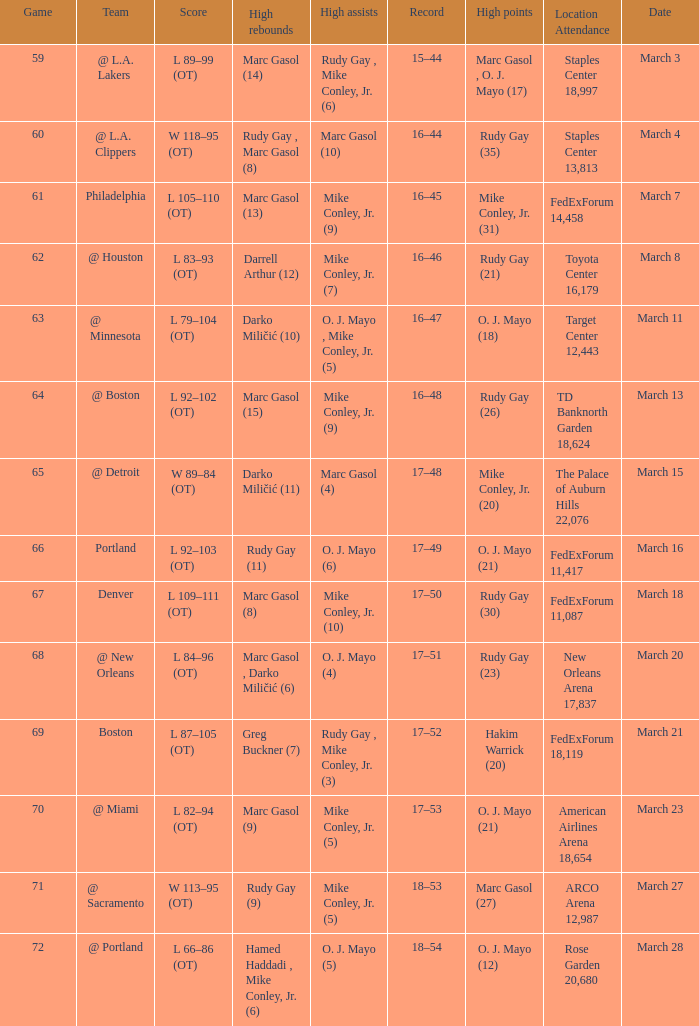What was the location and attendance for game 60? Staples Center 13,813. 